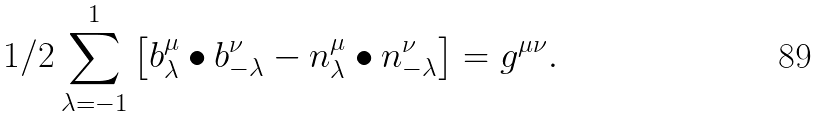<formula> <loc_0><loc_0><loc_500><loc_500>1 / 2 \sum _ { \lambda = - 1 } ^ { 1 } \left [ b _ { \lambda } ^ { \mu } \bullet b _ { - \lambda } ^ { \nu } - n _ { \lambda } ^ { \mu } \bullet n _ { - \lambda } ^ { \nu } \right ] = g ^ { \mu \nu } .</formula> 